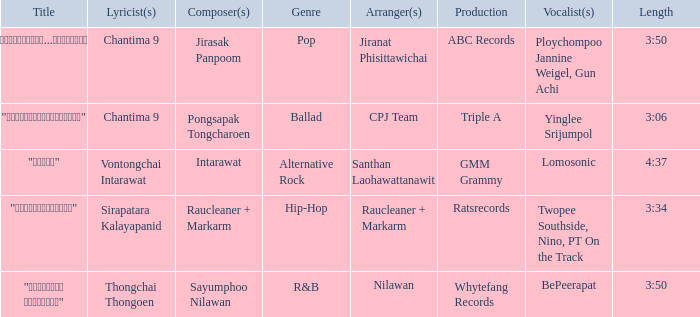Who was the composer of "ขอโทษ"? Intarawat. 